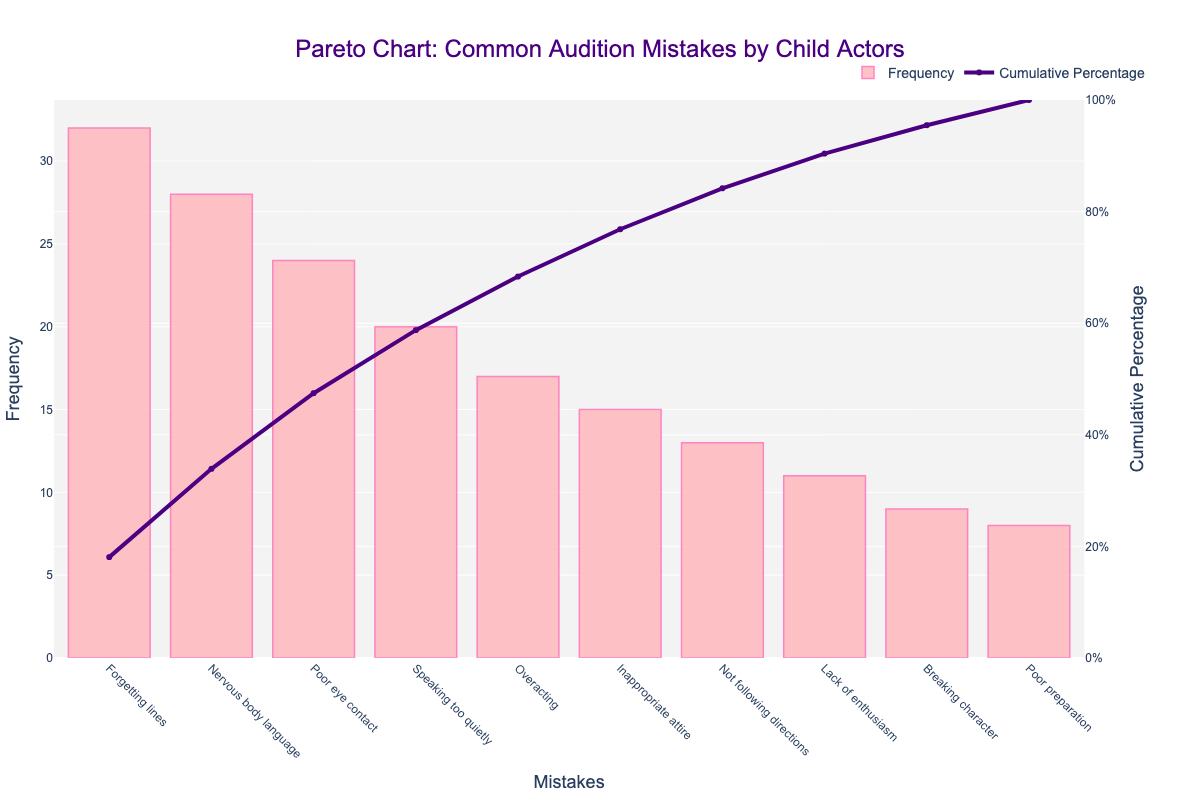What is the most common audition mistake made by child actors? The tallest bar in the Pareto chart represents the mistake with the highest frequency, which is "Forgetting lines" at 32.
Answer: Forgetting lines What percentage of the audition mistakes does "Forgetting lines" and "Nervous body language" together account for? "Forgetting lines" has a frequency of 32 and "Nervous body language" has 28. Their combined frequency is 60. To find the percentage, sum the total frequencies (32+28+24+20+17+15+13+11+9+8=177) and calculate (60/177*100).
Answer: 33.9% How many mistakes have a frequency higher than 20? By looking at the bars, we find that "Forgetting lines," "Nervous body language," "Poor eye contact," and "Speaking too quietly" all have frequencies higher than 20.
Answer: 4 Which mistake crosses the 80% cumulative percentage mark? By following the cumulative percentage line, we can see that "Overacting" is the first mistake where the cumulative percentage exceeds 80%.
Answer: Overacting Is the frequency of "Not following directions" higher or lower than "Inappropriate attire"? The Pareto chart indicates that "Not following directions" has a frequency of 13, which is lower than "Inappropriate attire" at 15.
Answer: Lower What is the cumulative percentage after accounting for 5 most frequent mistakes? Summing up the frequencies of the top 5 mistakes: 32 (Forgetting lines) + 28 (Nervous body language) + 24 (Poor eye contact) + 20 (Speaking too quietly) + 17 (Overacting) = 121. The cumulative percentage is (121 / 177) * 100.
Answer: 68.4% Which color represents the bars? The bars in the Pareto chart are represented in a light pink color.
Answer: Light pink How does the frequency of "Poor preparation" compare to the frequency of "Breaking character"? "Poor preparation" has a frequency of 8, while "Breaking character" has a frequency of 9. Comparing the two, "Poor preparation" has a lower frequency.
Answer: Lower When did the cumulative percentage line turn steeply upward? The cumulative percentage line noticeably turns steeply upward from the beginning due to high initial frequencies of mistakes such as "Forgetting lines" and "Nervous body language."
Answer: At the beginning 